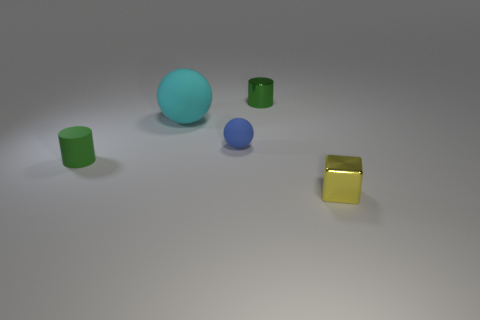Are there fewer small shiny cylinders that are on the left side of the tiny green metal object than yellow metallic objects that are on the right side of the small blue object?
Keep it short and to the point. Yes. There is a tiny metal thing that is to the right of the object behind the big object; what shape is it?
Offer a terse response. Cube. Is there any other thing of the same color as the tiny ball?
Ensure brevity in your answer.  No. Do the tiny rubber cylinder and the tiny shiny cylinder have the same color?
Give a very brief answer. Yes. What number of yellow things are either matte spheres or small metal cylinders?
Give a very brief answer. 0. Are there fewer small yellow metallic cubes that are on the left side of the cyan object than big brown shiny spheres?
Make the answer very short. No. What number of green metal cylinders are behind the shiny thing behind the small cube?
Provide a succinct answer. 0. How many other objects are the same size as the blue matte thing?
Keep it short and to the point. 3. How many objects are either green cylinders or tiny matte objects that are to the right of the large object?
Your answer should be very brief. 3. Are there fewer big matte things than tiny cyan matte balls?
Your answer should be very brief. No. 